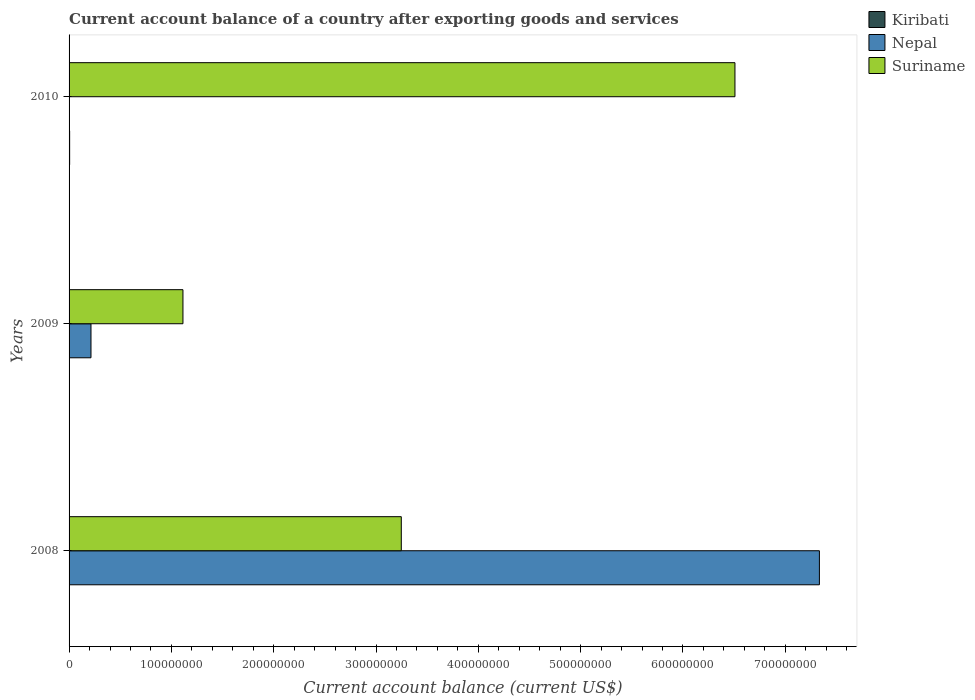How many bars are there on the 2nd tick from the bottom?
Offer a terse response. 2. What is the account balance in Suriname in 2010?
Keep it short and to the point. 6.51e+08. Across all years, what is the maximum account balance in Nepal?
Offer a terse response. 7.33e+08. Across all years, what is the minimum account balance in Suriname?
Provide a short and direct response. 1.11e+08. What is the total account balance in Nepal in the graph?
Offer a very short reply. 7.55e+08. What is the difference between the account balance in Suriname in 2008 and that in 2009?
Provide a short and direct response. 2.13e+08. What is the difference between the account balance in Kiribati in 2010 and the account balance in Nepal in 2009?
Your response must be concise. -2.09e+07. What is the average account balance in Nepal per year?
Ensure brevity in your answer.  2.52e+08. In the year 2009, what is the difference between the account balance in Nepal and account balance in Suriname?
Make the answer very short. -8.99e+07. Is the account balance in Suriname in 2009 less than that in 2010?
Ensure brevity in your answer.  Yes. What is the difference between the highest and the second highest account balance in Suriname?
Your answer should be compact. 3.26e+08. What is the difference between the highest and the lowest account balance in Suriname?
Provide a succinct answer. 5.40e+08. Is it the case that in every year, the sum of the account balance in Suriname and account balance in Kiribati is greater than the account balance in Nepal?
Your answer should be compact. No. How many bars are there?
Your answer should be compact. 6. Are the values on the major ticks of X-axis written in scientific E-notation?
Offer a terse response. No. Does the graph contain any zero values?
Provide a succinct answer. Yes. Does the graph contain grids?
Provide a short and direct response. No. Where does the legend appear in the graph?
Your answer should be compact. Top right. How are the legend labels stacked?
Offer a very short reply. Vertical. What is the title of the graph?
Make the answer very short. Current account balance of a country after exporting goods and services. Does "Venezuela" appear as one of the legend labels in the graph?
Provide a short and direct response. No. What is the label or title of the X-axis?
Ensure brevity in your answer.  Current account balance (current US$). What is the Current account balance (current US$) of Kiribati in 2008?
Your answer should be very brief. 0. What is the Current account balance (current US$) of Nepal in 2008?
Provide a short and direct response. 7.33e+08. What is the Current account balance (current US$) in Suriname in 2008?
Offer a terse response. 3.25e+08. What is the Current account balance (current US$) in Nepal in 2009?
Your response must be concise. 2.14e+07. What is the Current account balance (current US$) in Suriname in 2009?
Give a very brief answer. 1.11e+08. What is the Current account balance (current US$) of Kiribati in 2010?
Provide a succinct answer. 5.53e+05. What is the Current account balance (current US$) of Nepal in 2010?
Offer a very short reply. 0. What is the Current account balance (current US$) of Suriname in 2010?
Offer a very short reply. 6.51e+08. Across all years, what is the maximum Current account balance (current US$) of Kiribati?
Provide a succinct answer. 5.53e+05. Across all years, what is the maximum Current account balance (current US$) of Nepal?
Your answer should be very brief. 7.33e+08. Across all years, what is the maximum Current account balance (current US$) in Suriname?
Make the answer very short. 6.51e+08. Across all years, what is the minimum Current account balance (current US$) in Suriname?
Give a very brief answer. 1.11e+08. What is the total Current account balance (current US$) in Kiribati in the graph?
Give a very brief answer. 5.53e+05. What is the total Current account balance (current US$) in Nepal in the graph?
Your answer should be compact. 7.55e+08. What is the total Current account balance (current US$) of Suriname in the graph?
Your response must be concise. 1.09e+09. What is the difference between the Current account balance (current US$) in Nepal in 2008 and that in 2009?
Provide a short and direct response. 7.12e+08. What is the difference between the Current account balance (current US$) of Suriname in 2008 and that in 2009?
Your answer should be very brief. 2.13e+08. What is the difference between the Current account balance (current US$) of Suriname in 2008 and that in 2010?
Your answer should be compact. -3.26e+08. What is the difference between the Current account balance (current US$) in Suriname in 2009 and that in 2010?
Keep it short and to the point. -5.40e+08. What is the difference between the Current account balance (current US$) in Nepal in 2008 and the Current account balance (current US$) in Suriname in 2009?
Make the answer very short. 6.22e+08. What is the difference between the Current account balance (current US$) of Nepal in 2008 and the Current account balance (current US$) of Suriname in 2010?
Offer a very short reply. 8.25e+07. What is the difference between the Current account balance (current US$) in Nepal in 2009 and the Current account balance (current US$) in Suriname in 2010?
Provide a succinct answer. -6.29e+08. What is the average Current account balance (current US$) of Kiribati per year?
Your response must be concise. 1.84e+05. What is the average Current account balance (current US$) of Nepal per year?
Your response must be concise. 2.52e+08. What is the average Current account balance (current US$) in Suriname per year?
Your answer should be very brief. 3.62e+08. In the year 2008, what is the difference between the Current account balance (current US$) in Nepal and Current account balance (current US$) in Suriname?
Provide a succinct answer. 4.09e+08. In the year 2009, what is the difference between the Current account balance (current US$) in Nepal and Current account balance (current US$) in Suriname?
Make the answer very short. -8.99e+07. In the year 2010, what is the difference between the Current account balance (current US$) in Kiribati and Current account balance (current US$) in Suriname?
Your answer should be very brief. -6.50e+08. What is the ratio of the Current account balance (current US$) in Nepal in 2008 to that in 2009?
Your answer should be compact. 34.25. What is the ratio of the Current account balance (current US$) of Suriname in 2008 to that in 2009?
Ensure brevity in your answer.  2.92. What is the ratio of the Current account balance (current US$) of Suriname in 2008 to that in 2010?
Offer a terse response. 0.5. What is the ratio of the Current account balance (current US$) in Suriname in 2009 to that in 2010?
Make the answer very short. 0.17. What is the difference between the highest and the second highest Current account balance (current US$) of Suriname?
Your answer should be very brief. 3.26e+08. What is the difference between the highest and the lowest Current account balance (current US$) in Kiribati?
Make the answer very short. 5.53e+05. What is the difference between the highest and the lowest Current account balance (current US$) of Nepal?
Your answer should be compact. 7.33e+08. What is the difference between the highest and the lowest Current account balance (current US$) in Suriname?
Give a very brief answer. 5.40e+08. 